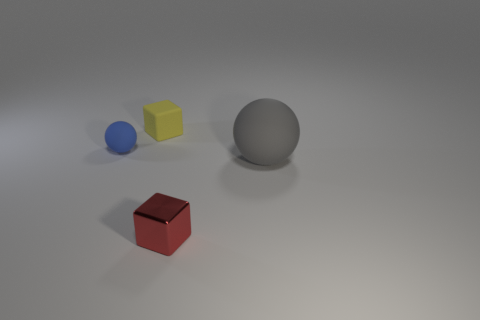Add 4 big gray metallic cubes. How many objects exist? 8 Add 1 yellow things. How many yellow things are left? 2 Add 3 tiny green matte objects. How many tiny green matte objects exist? 3 Subtract 0 green balls. How many objects are left? 4 Subtract all gray matte objects. Subtract all small shiny blocks. How many objects are left? 2 